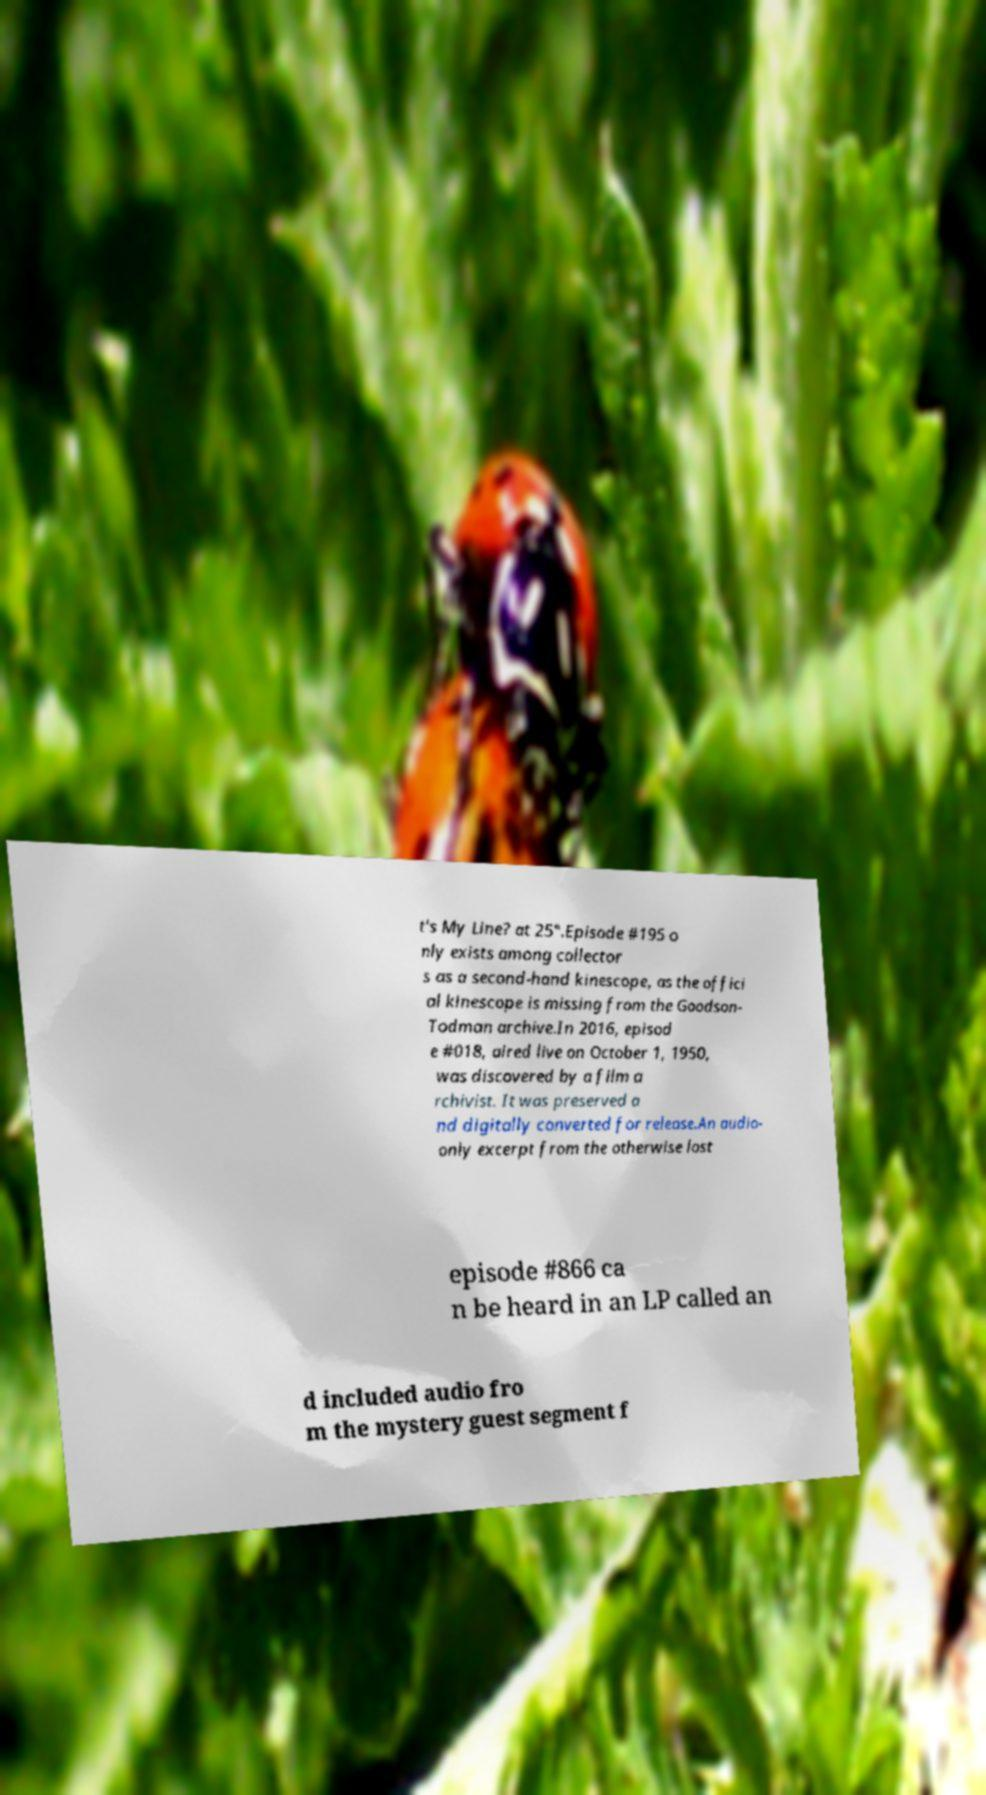Can you read and provide the text displayed in the image?This photo seems to have some interesting text. Can you extract and type it out for me? t's My Line? at 25".Episode #195 o nly exists among collector s as a second-hand kinescope, as the offici al kinescope is missing from the Goodson- Todman archive.In 2016, episod e #018, aired live on October 1, 1950, was discovered by a film a rchivist. It was preserved a nd digitally converted for release.An audio- only excerpt from the otherwise lost episode #866 ca n be heard in an LP called an d included audio fro m the mystery guest segment f 